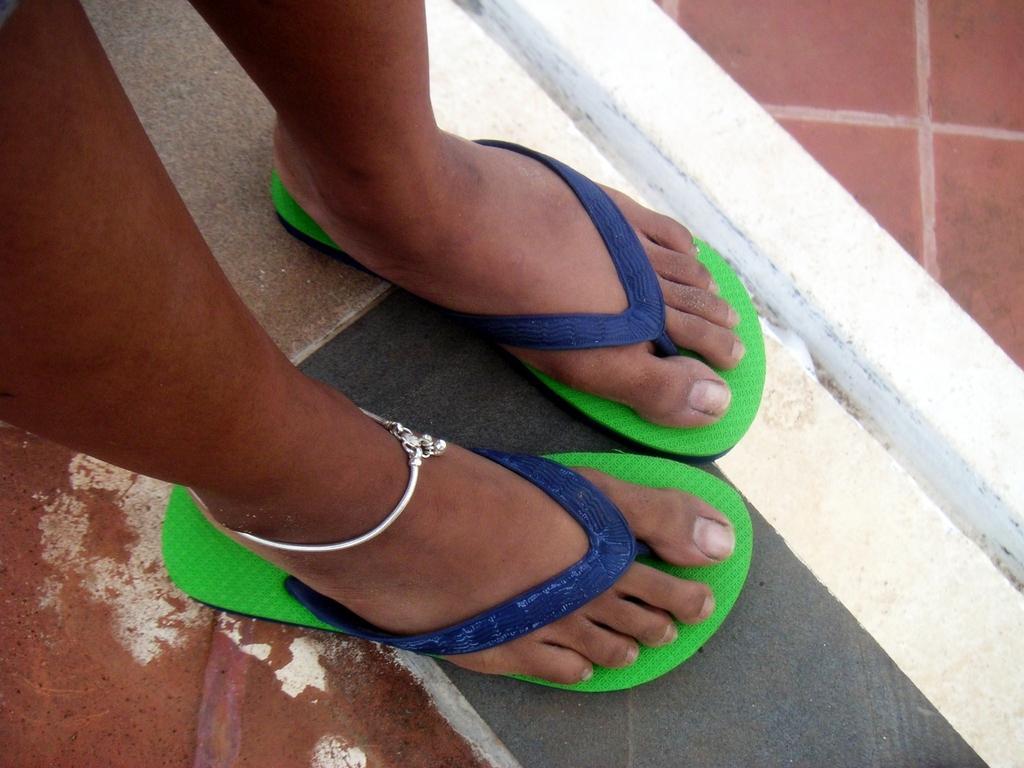In one or two sentences, can you explain what this image depicts? A person is wearing slippers and an anklet. 